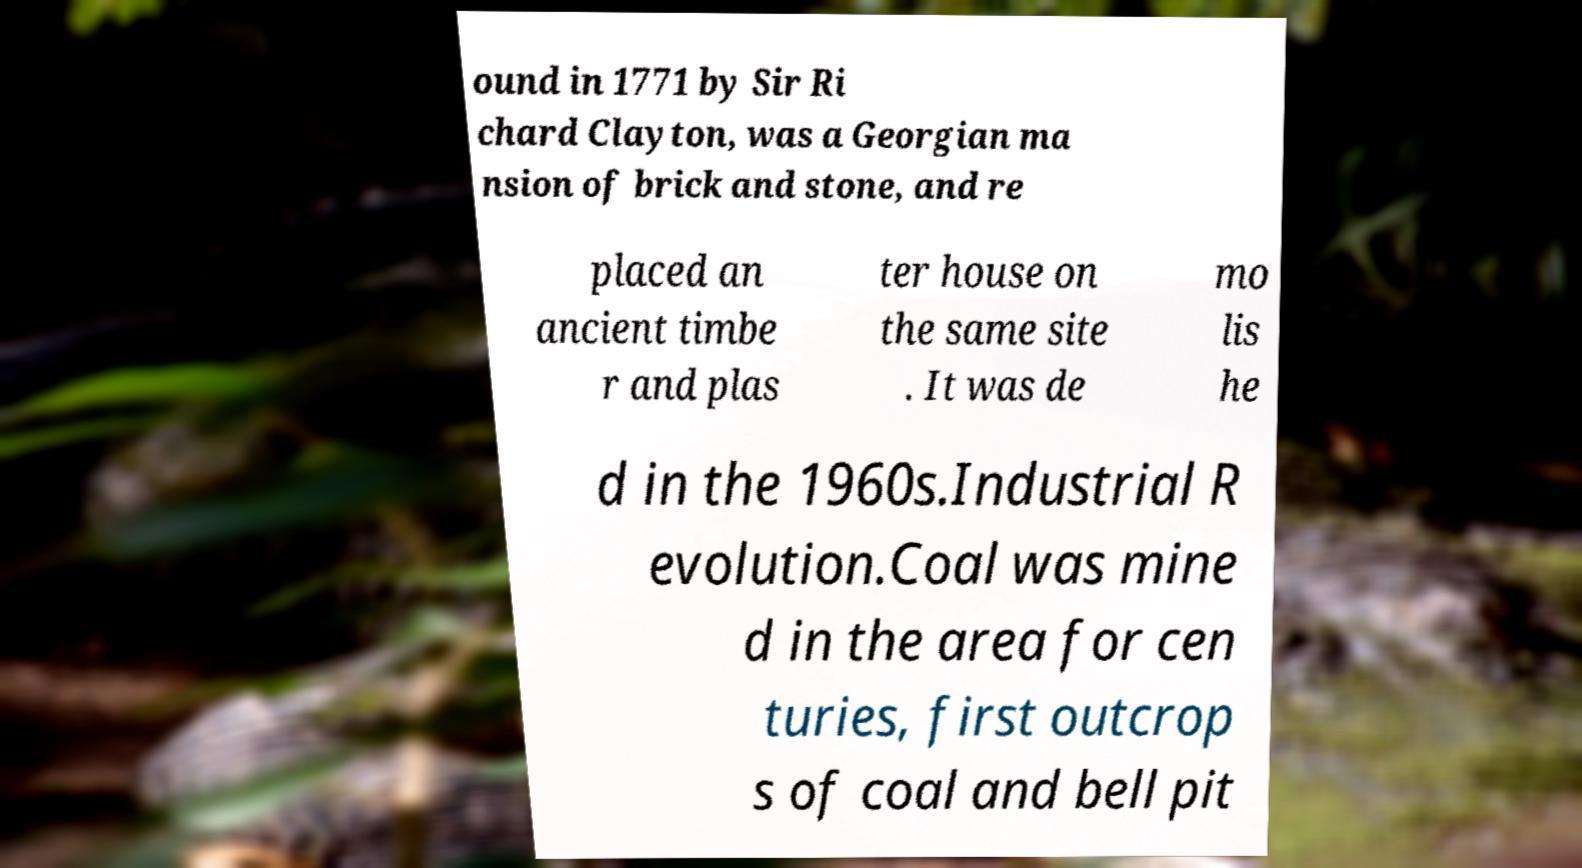Can you read and provide the text displayed in the image?This photo seems to have some interesting text. Can you extract and type it out for me? ound in 1771 by Sir Ri chard Clayton, was a Georgian ma nsion of brick and stone, and re placed an ancient timbe r and plas ter house on the same site . It was de mo lis he d in the 1960s.Industrial R evolution.Coal was mine d in the area for cen turies, first outcrop s of coal and bell pit 